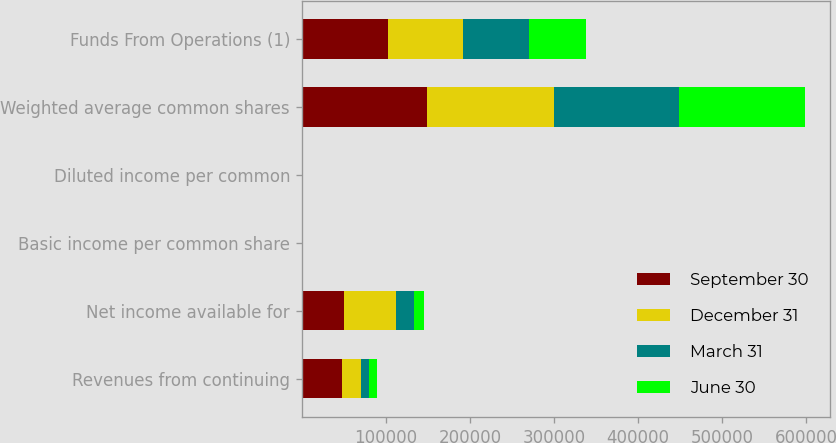Convert chart. <chart><loc_0><loc_0><loc_500><loc_500><stacked_bar_chart><ecel><fcel>Revenues from continuing<fcel>Net income available for<fcel>Basic income per common share<fcel>Diluted income per common<fcel>Weighted average common shares<fcel>Funds From Operations (1)<nl><fcel>September 30<fcel>47927<fcel>50196<fcel>0.37<fcel>0.37<fcel>149020<fcel>102788<nl><fcel>December 31<fcel>22474<fcel>61734<fcel>0.46<fcel>0.45<fcel>150947<fcel>88787<nl><fcel>March 31<fcel>9718<fcel>21717<fcel>0.16<fcel>0.16<fcel>149364<fcel>78756<nl><fcel>June 30<fcel>10006<fcel>11448<fcel>0.08<fcel>0.08<fcel>149265<fcel>67677<nl></chart> 